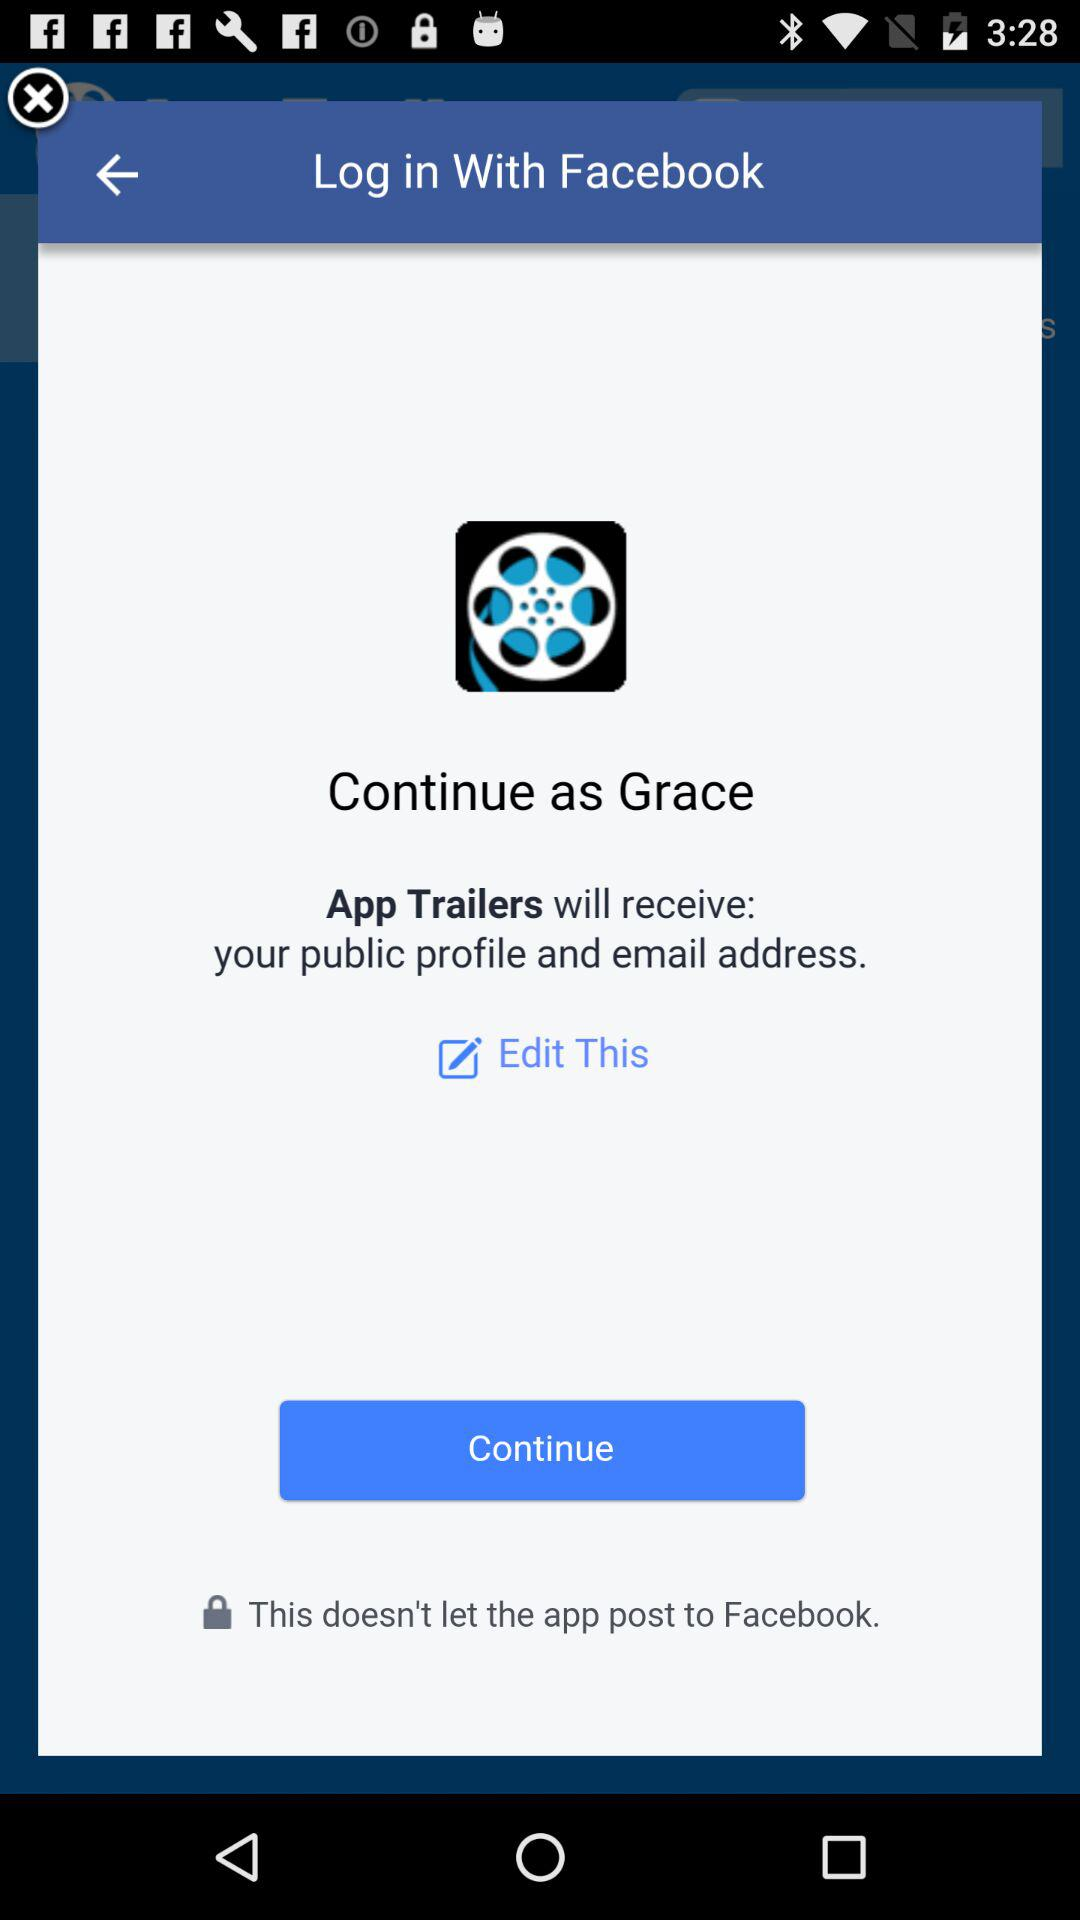What application is asking for permission? The application asking for permission is "App Trailers". 